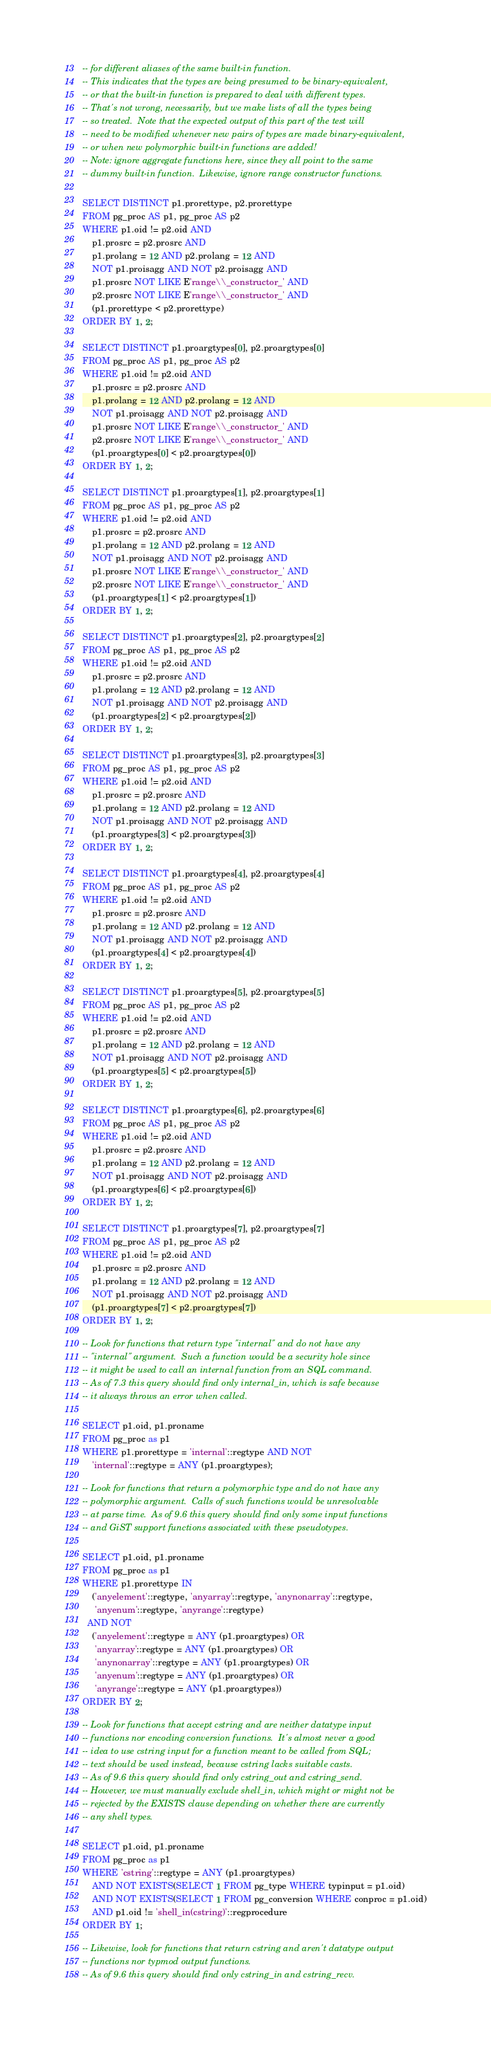Convert code to text. <code><loc_0><loc_0><loc_500><loc_500><_SQL_>-- for different aliases of the same built-in function.
-- This indicates that the types are being presumed to be binary-equivalent,
-- or that the built-in function is prepared to deal with different types.
-- That's not wrong, necessarily, but we make lists of all the types being
-- so treated.  Note that the expected output of this part of the test will
-- need to be modified whenever new pairs of types are made binary-equivalent,
-- or when new polymorphic built-in functions are added!
-- Note: ignore aggregate functions here, since they all point to the same
-- dummy built-in function.  Likewise, ignore range constructor functions.

SELECT DISTINCT p1.prorettype, p2.prorettype
FROM pg_proc AS p1, pg_proc AS p2
WHERE p1.oid != p2.oid AND
    p1.prosrc = p2.prosrc AND
    p1.prolang = 12 AND p2.prolang = 12 AND
    NOT p1.proisagg AND NOT p2.proisagg AND
    p1.prosrc NOT LIKE E'range\\_constructor_' AND
    p2.prosrc NOT LIKE E'range\\_constructor_' AND
    (p1.prorettype < p2.prorettype)
ORDER BY 1, 2;

SELECT DISTINCT p1.proargtypes[0], p2.proargtypes[0]
FROM pg_proc AS p1, pg_proc AS p2
WHERE p1.oid != p2.oid AND
    p1.prosrc = p2.prosrc AND
    p1.prolang = 12 AND p2.prolang = 12 AND
    NOT p1.proisagg AND NOT p2.proisagg AND
    p1.prosrc NOT LIKE E'range\\_constructor_' AND
    p2.prosrc NOT LIKE E'range\\_constructor_' AND
    (p1.proargtypes[0] < p2.proargtypes[0])
ORDER BY 1, 2;

SELECT DISTINCT p1.proargtypes[1], p2.proargtypes[1]
FROM pg_proc AS p1, pg_proc AS p2
WHERE p1.oid != p2.oid AND
    p1.prosrc = p2.prosrc AND
    p1.prolang = 12 AND p2.prolang = 12 AND
    NOT p1.proisagg AND NOT p2.proisagg AND
    p1.prosrc NOT LIKE E'range\\_constructor_' AND
    p2.prosrc NOT LIKE E'range\\_constructor_' AND
    (p1.proargtypes[1] < p2.proargtypes[1])
ORDER BY 1, 2;

SELECT DISTINCT p1.proargtypes[2], p2.proargtypes[2]
FROM pg_proc AS p1, pg_proc AS p2
WHERE p1.oid != p2.oid AND
    p1.prosrc = p2.prosrc AND
    p1.prolang = 12 AND p2.prolang = 12 AND
    NOT p1.proisagg AND NOT p2.proisagg AND
    (p1.proargtypes[2] < p2.proargtypes[2])
ORDER BY 1, 2;

SELECT DISTINCT p1.proargtypes[3], p2.proargtypes[3]
FROM pg_proc AS p1, pg_proc AS p2
WHERE p1.oid != p2.oid AND
    p1.prosrc = p2.prosrc AND
    p1.prolang = 12 AND p2.prolang = 12 AND
    NOT p1.proisagg AND NOT p2.proisagg AND
    (p1.proargtypes[3] < p2.proargtypes[3])
ORDER BY 1, 2;

SELECT DISTINCT p1.proargtypes[4], p2.proargtypes[4]
FROM pg_proc AS p1, pg_proc AS p2
WHERE p1.oid != p2.oid AND
    p1.prosrc = p2.prosrc AND
    p1.prolang = 12 AND p2.prolang = 12 AND
    NOT p1.proisagg AND NOT p2.proisagg AND
    (p1.proargtypes[4] < p2.proargtypes[4])
ORDER BY 1, 2;

SELECT DISTINCT p1.proargtypes[5], p2.proargtypes[5]
FROM pg_proc AS p1, pg_proc AS p2
WHERE p1.oid != p2.oid AND
    p1.prosrc = p2.prosrc AND
    p1.prolang = 12 AND p2.prolang = 12 AND
    NOT p1.proisagg AND NOT p2.proisagg AND
    (p1.proargtypes[5] < p2.proargtypes[5])
ORDER BY 1, 2;

SELECT DISTINCT p1.proargtypes[6], p2.proargtypes[6]
FROM pg_proc AS p1, pg_proc AS p2
WHERE p1.oid != p2.oid AND
    p1.prosrc = p2.prosrc AND
    p1.prolang = 12 AND p2.prolang = 12 AND
    NOT p1.proisagg AND NOT p2.proisagg AND
    (p1.proargtypes[6] < p2.proargtypes[6])
ORDER BY 1, 2;

SELECT DISTINCT p1.proargtypes[7], p2.proargtypes[7]
FROM pg_proc AS p1, pg_proc AS p2
WHERE p1.oid != p2.oid AND
    p1.prosrc = p2.prosrc AND
    p1.prolang = 12 AND p2.prolang = 12 AND
    NOT p1.proisagg AND NOT p2.proisagg AND
    (p1.proargtypes[7] < p2.proargtypes[7])
ORDER BY 1, 2;

-- Look for functions that return type "internal" and do not have any
-- "internal" argument.  Such a function would be a security hole since
-- it might be used to call an internal function from an SQL command.
-- As of 7.3 this query should find only internal_in, which is safe because
-- it always throws an error when called.

SELECT p1.oid, p1.proname
FROM pg_proc as p1
WHERE p1.prorettype = 'internal'::regtype AND NOT
    'internal'::regtype = ANY (p1.proargtypes);

-- Look for functions that return a polymorphic type and do not have any
-- polymorphic argument.  Calls of such functions would be unresolvable
-- at parse time.  As of 9.6 this query should find only some input functions
-- and GiST support functions associated with these pseudotypes.

SELECT p1.oid, p1.proname
FROM pg_proc as p1
WHERE p1.prorettype IN
    ('anyelement'::regtype, 'anyarray'::regtype, 'anynonarray'::regtype,
     'anyenum'::regtype, 'anyrange'::regtype)
  AND NOT
    ('anyelement'::regtype = ANY (p1.proargtypes) OR
     'anyarray'::regtype = ANY (p1.proargtypes) OR
     'anynonarray'::regtype = ANY (p1.proargtypes) OR
     'anyenum'::regtype = ANY (p1.proargtypes) OR
     'anyrange'::regtype = ANY (p1.proargtypes))
ORDER BY 2;

-- Look for functions that accept cstring and are neither datatype input
-- functions nor encoding conversion functions.  It's almost never a good
-- idea to use cstring input for a function meant to be called from SQL;
-- text should be used instead, because cstring lacks suitable casts.
-- As of 9.6 this query should find only cstring_out and cstring_send.
-- However, we must manually exclude shell_in, which might or might not be
-- rejected by the EXISTS clause depending on whether there are currently
-- any shell types.

SELECT p1.oid, p1.proname
FROM pg_proc as p1
WHERE 'cstring'::regtype = ANY (p1.proargtypes)
    AND NOT EXISTS(SELECT 1 FROM pg_type WHERE typinput = p1.oid)
    AND NOT EXISTS(SELECT 1 FROM pg_conversion WHERE conproc = p1.oid)
    AND p1.oid != 'shell_in(cstring)'::regprocedure
ORDER BY 1;

-- Likewise, look for functions that return cstring and aren't datatype output
-- functions nor typmod output functions.
-- As of 9.6 this query should find only cstring_in and cstring_recv.</code> 